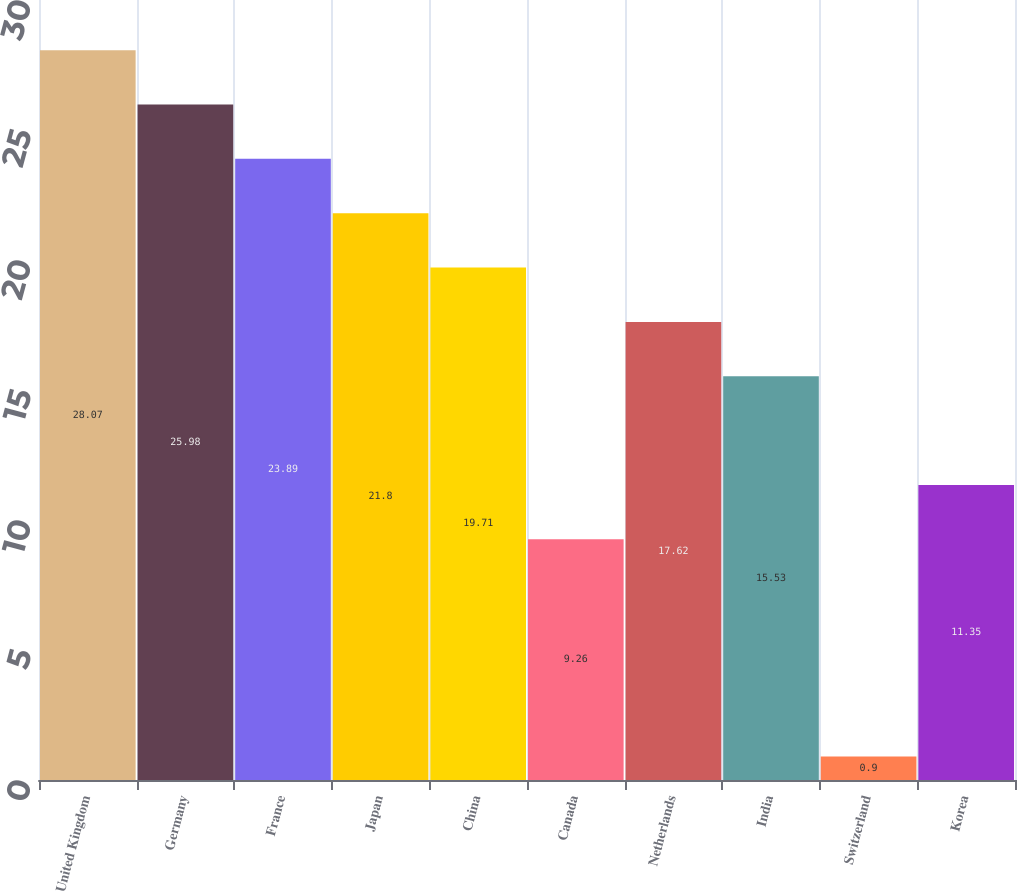<chart> <loc_0><loc_0><loc_500><loc_500><bar_chart><fcel>United Kingdom<fcel>Germany<fcel>France<fcel>Japan<fcel>China<fcel>Canada<fcel>Netherlands<fcel>India<fcel>Switzerland<fcel>Korea<nl><fcel>28.07<fcel>25.98<fcel>23.89<fcel>21.8<fcel>19.71<fcel>9.26<fcel>17.62<fcel>15.53<fcel>0.9<fcel>11.35<nl></chart> 